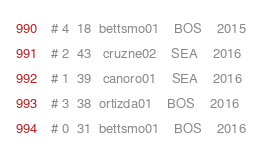Convert code to text. <code><loc_0><loc_0><loc_500><loc_500><_Python_># 4  18  bettsmo01    BOS    2015
# 2  43   cruzne02    SEA    2016
# 1  39   canoro01    SEA    2016
# 3  38  ortizda01    BOS    2016
# 0  31  bettsmo01    BOS    2016
</code> 